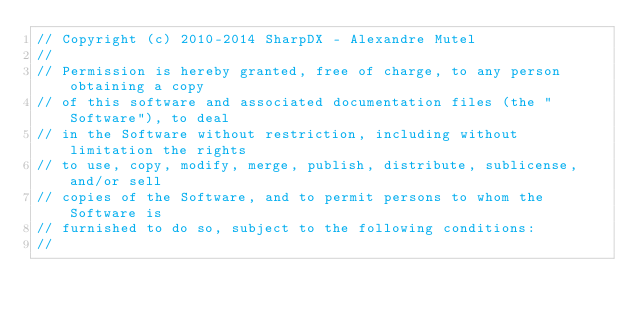Convert code to text. <code><loc_0><loc_0><loc_500><loc_500><_C#_>// Copyright (c) 2010-2014 SharpDX - Alexandre Mutel
// 
// Permission is hereby granted, free of charge, to any person obtaining a copy
// of this software and associated documentation files (the "Software"), to deal
// in the Software without restriction, including without limitation the rights
// to use, copy, modify, merge, publish, distribute, sublicense, and/or sell
// copies of the Software, and to permit persons to whom the Software is
// furnished to do so, subject to the following conditions:
// </code> 